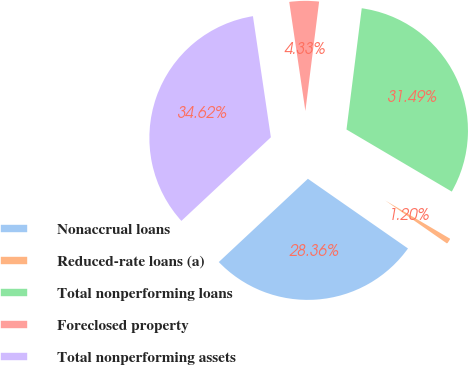Convert chart to OTSL. <chart><loc_0><loc_0><loc_500><loc_500><pie_chart><fcel>Nonaccrual loans<fcel>Reduced-rate loans (a)<fcel>Total nonperforming loans<fcel>Foreclosed property<fcel>Total nonperforming assets<nl><fcel>28.36%<fcel>1.2%<fcel>31.49%<fcel>4.33%<fcel>34.62%<nl></chart> 